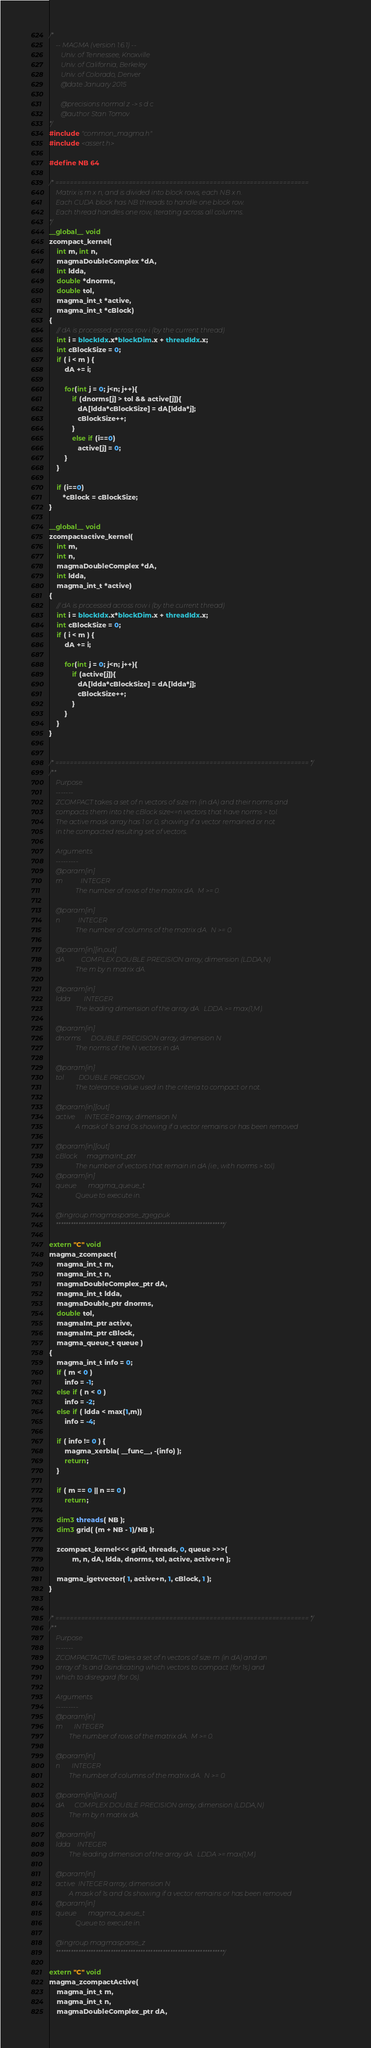<code> <loc_0><loc_0><loc_500><loc_500><_Cuda_>/*
    -- MAGMA (version 1.6.1) --
       Univ. of Tennessee, Knoxville
       Univ. of California, Berkeley
       Univ. of Colorado, Denver
       @date January 2015

       @precisions normal z -> s d c
       @author Stan Tomov
*/
#include "common_magma.h"
#include <assert.h>

#define NB 64

/* =====================================================================
    Matrix is m x n, and is divided into block rows, each NB x n.
    Each CUDA block has NB threads to handle one block row.
    Each thread handles one row, iterating across all columns.
*/
__global__ void
zcompact_kernel(
    int m, int n,
    magmaDoubleComplex *dA, 
    int ldda,
    double *dnorms, 
    double tol,
    magma_int_t *active, 
    magma_int_t *cBlock)
{
    // dA is processed across row i (by the current thread)
    int i = blockIdx.x*blockDim.x + threadIdx.x;
    int cBlockSize = 0;
    if ( i < m ) {
        dA += i;
        
        for(int j = 0; j<n; j++){
            if (dnorms[j] > tol && active[j]){
               dA[ldda*cBlockSize] = dA[ldda*j];
               cBlockSize++;
            }
            else if (i==0)
               active[j] = 0;
        }
    }

    if (i==0)
       *cBlock = cBlockSize;
}

__global__ void
zcompactactive_kernel(
    int m, 
    int n,
    magmaDoubleComplex *dA, 
    int ldda,
    magma_int_t *active)
{
    // dA is processed across row i (by the current thread)
    int i = blockIdx.x*blockDim.x + threadIdx.x;
    int cBlockSize = 0;
    if ( i < m ) {
        dA += i;

        for(int j = 0; j<n; j++){
            if (active[j]){
               dA[ldda*cBlockSize] = dA[ldda*j];
               cBlockSize++;
            }
        }
    }
}


/* ===================================================================== */
/**
    Purpose
    -------
    ZCOMPACT takes a set of n vectors of size m (in dA) and their norms and
    compacts them into the cBlock size<=n vectors that have norms > tol.
    The active mask array has 1 or 0, showing if a vector remained or not
    in the compacted resulting set of vectors.
    
    Arguments
    ---------
    @param[in]
    m           INTEGER
                The number of rows of the matrix dA.  M >= 0.
    
    @param[in]
    n           INTEGER
                The number of columns of the matrix dA.  N >= 0.
    
    @param[in][in,out]
    dA          COMPLEX DOUBLE PRECISION array, dimension (LDDA,N)
                The m by n matrix dA.
    
    @param[in]
    ldda        INTEGER
                The leading dimension of the array dA.  LDDA >= max(1,M).
    
    @param[in]
    dnorms      DOUBLE PRECISION array, dimension N
                The norms of the N vectors in dA

    @param[in]
    tol         DOUBLE PRECISON
                The tolerance value used in the criteria to compact or not.

    @param[in][out]
    active      INTEGER array, dimension N
                A mask of 1s and 0s showing if a vector remains or has been removed
            
    @param[in][out]
    cBlock      magmaInt_ptr
                The number of vectors that remain in dA (i.e., with norms > tol).
    @param[in]
    queue       magma_queue_t
                Queue to execute in.

    @ingroup magmasparse_zgegpuk
    ********************************************************************/

extern "C" void
magma_zcompact(
    magma_int_t m, 
    magma_int_t n,
    magmaDoubleComplex_ptr dA, 
    magma_int_t ldda,
    magmaDouble_ptr dnorms, 
    double tol, 
    magmaInt_ptr active,
    magmaInt_ptr cBlock,
    magma_queue_t queue )
{
    magma_int_t info = 0;
    if ( m < 0 )
        info = -1;
    else if ( n < 0 )
        info = -2;
    else if ( ldda < max(1,m))
        info = -4;
    
    if ( info != 0 ) {
        magma_xerbla( __func__, -(info) );
        return;
    }
    
    if ( m == 0 || n == 0 )
        return;
    
    dim3 threads( NB );
    dim3 grid( (m + NB - 1)/NB );
    
    zcompact_kernel<<< grid, threads, 0, queue >>>(
            m, n, dA, ldda, dnorms, tol, active, active+n );

    magma_igetvector( 1, active+n, 1, cBlock, 1 );
}


/* ===================================================================== */
/**
    Purpose
    -------
    ZCOMPACTACTIVE takes a set of n vectors of size m (in dA) and an
    array of 1s and 0sindicating which vectors to compact (for 1s) and
    which to disregard (for 0s).

    Arguments
    ---------
    @param[in]
    m       INTEGER
            The number of rows of the matrix dA.  M >= 0.

    @param[in]
    n       INTEGER
            The number of columns of the matrix dA.  N >= 0.

    @param[in][in,out]
    dA      COMPLEX DOUBLE PRECISION array, dimension (LDDA,N)
            The m by n matrix dA.

    @param[in]
    ldda    INTEGER
            The leading dimension of the array dA.  LDDA >= max(1,M).

    @param[in]
    active  INTEGER array, dimension N
            A mask of 1s and 0s showing if a vector remains or has been removed
    @param[in]
    queue       magma_queue_t
                Queue to execute in.

    @ingroup magmasparse_z
    ********************************************************************/

extern "C" void
magma_zcompactActive(
    magma_int_t m, 
    magma_int_t n,
    magmaDoubleComplex_ptr dA, </code> 